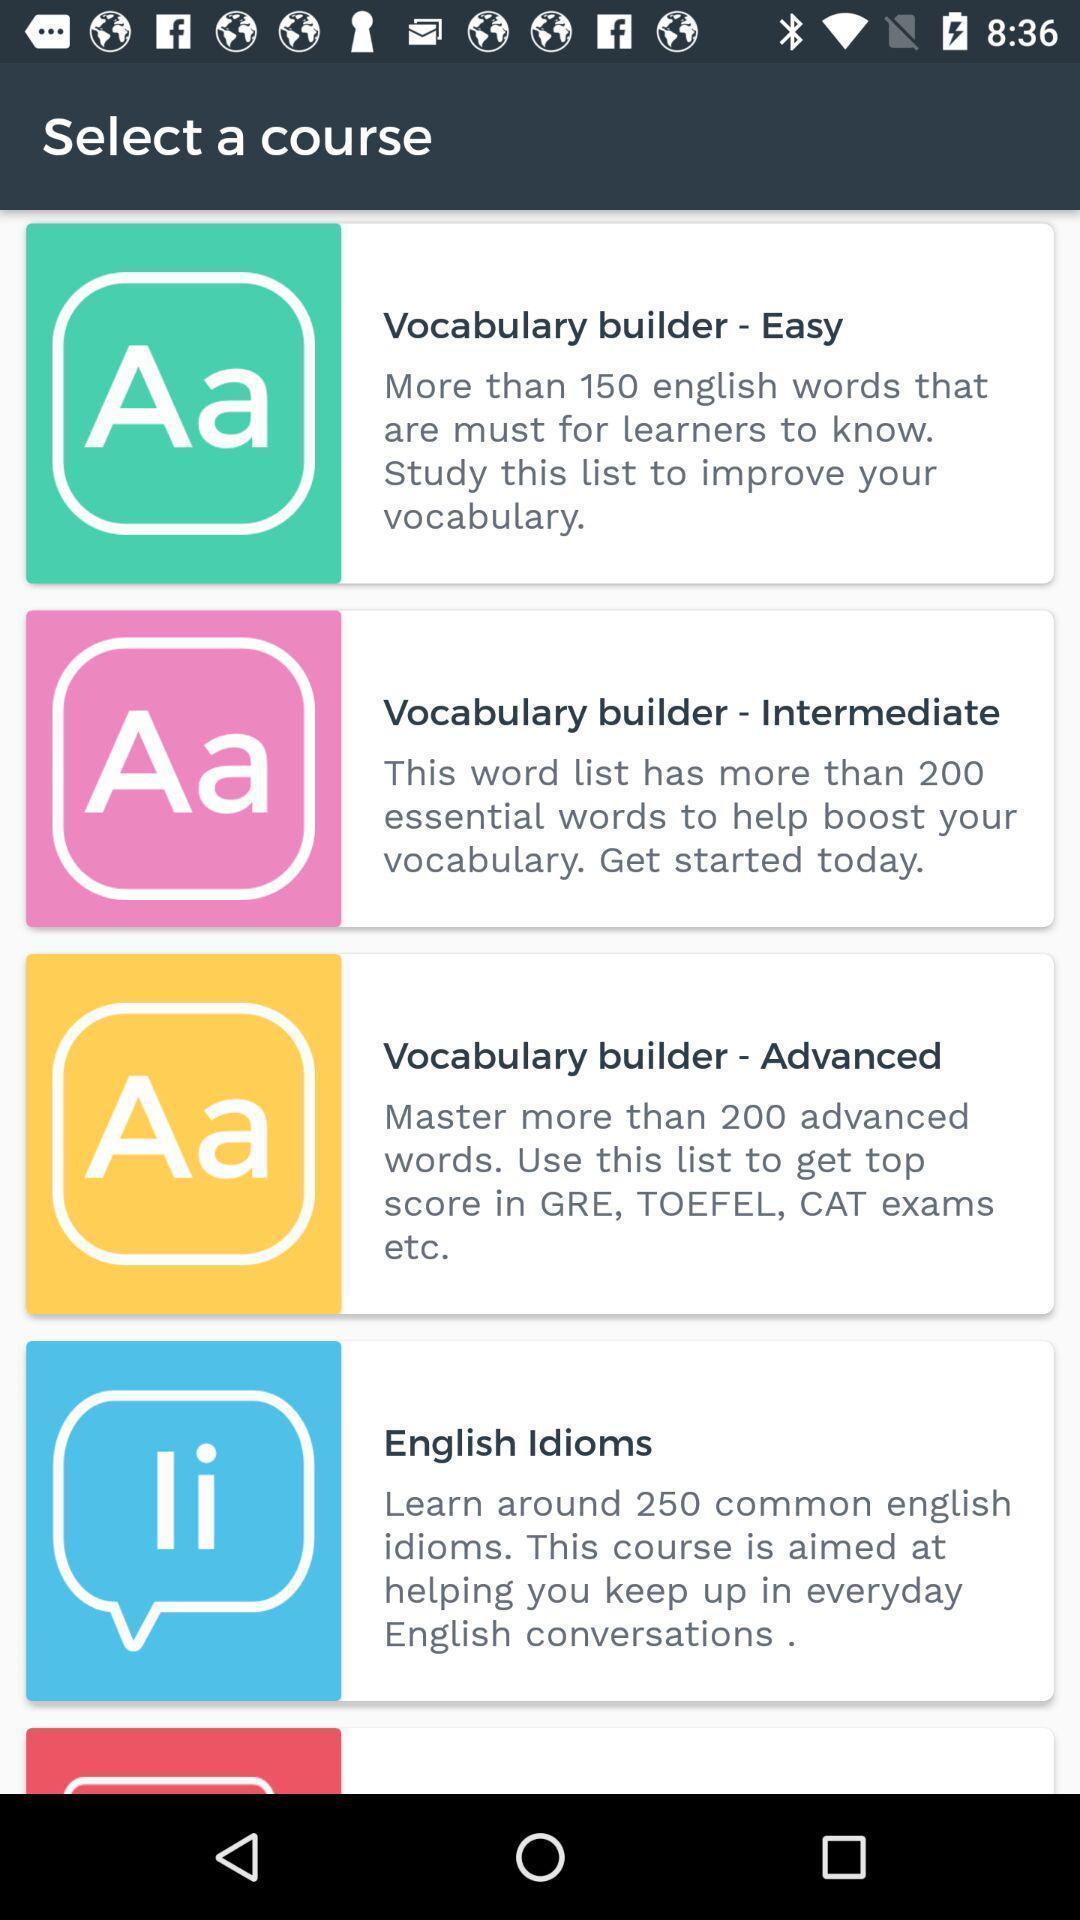Describe the visual elements of this screenshot. Screen shows list of courses in a learning app. 